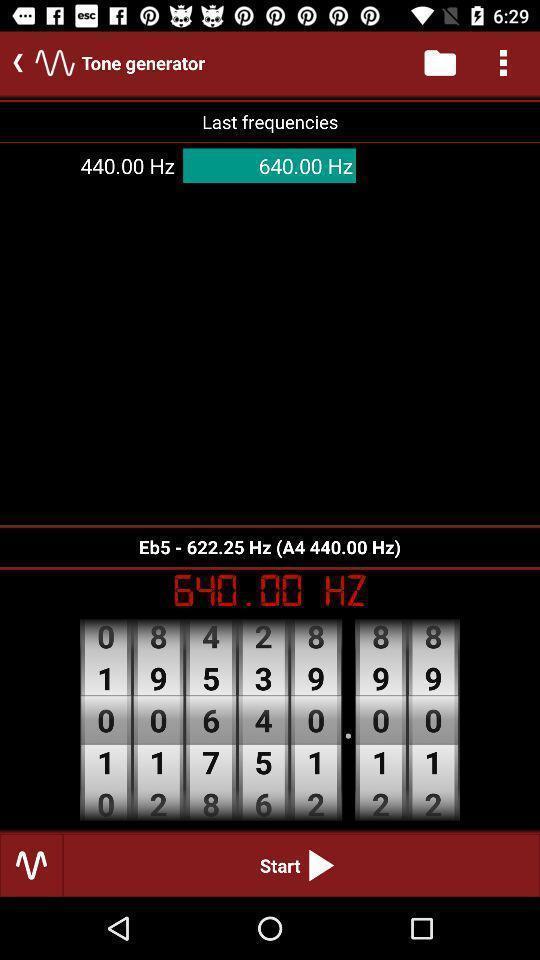Provide a description of this screenshot. Screen displaying the starting page. 